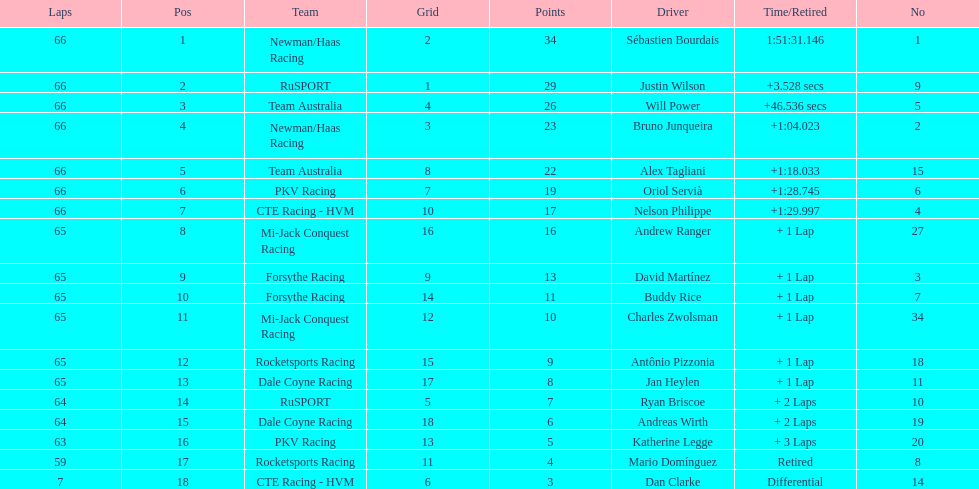What is the number of laps dan clarke completed? 7. 